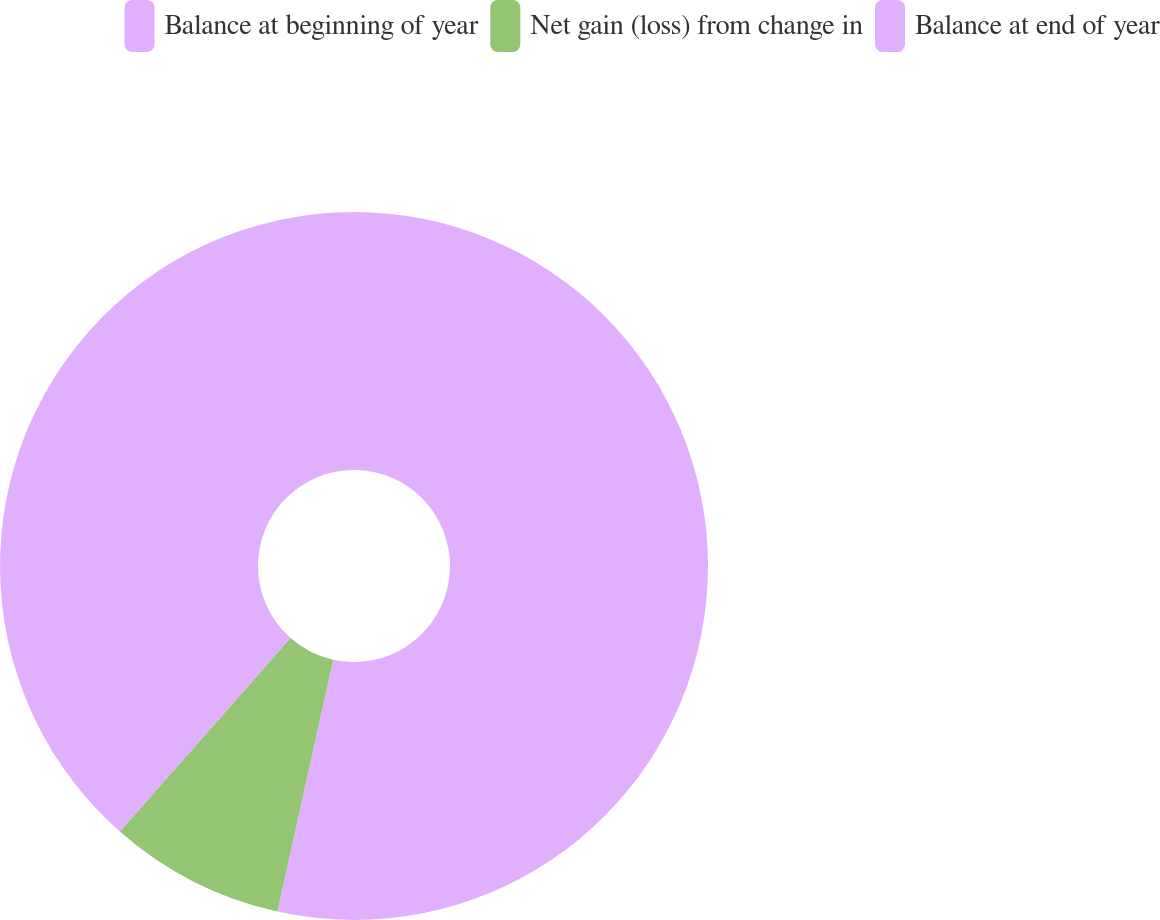<chart> <loc_0><loc_0><loc_500><loc_500><pie_chart><fcel>Balance at beginning of year<fcel>Net gain (loss) from change in<fcel>Balance at end of year<nl><fcel>53.47%<fcel>8.03%<fcel>38.5%<nl></chart> 